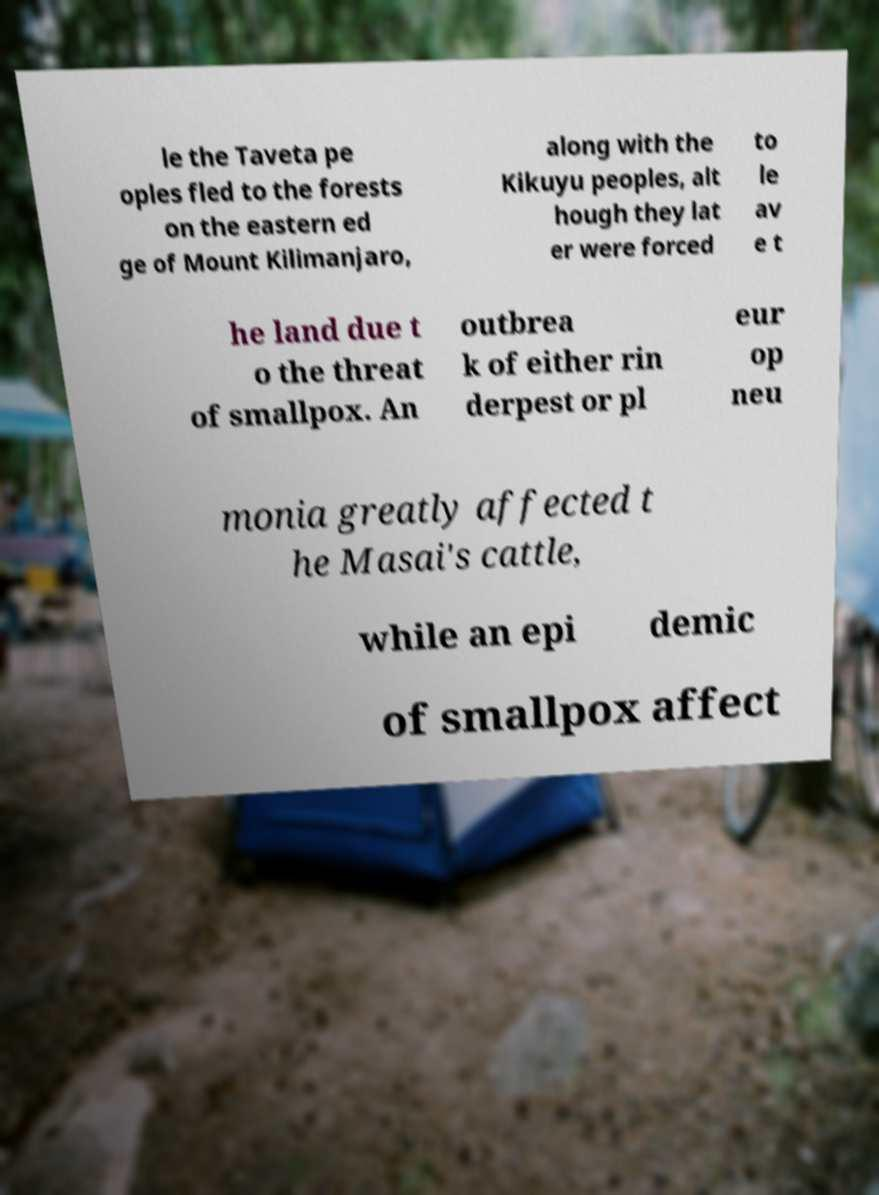What messages or text are displayed in this image? I need them in a readable, typed format. le the Taveta pe oples fled to the forests on the eastern ed ge of Mount Kilimanjaro, along with the Kikuyu peoples, alt hough they lat er were forced to le av e t he land due t o the threat of smallpox. An outbrea k of either rin derpest or pl eur op neu monia greatly affected t he Masai's cattle, while an epi demic of smallpox affect 